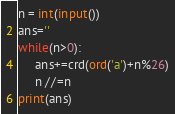Convert code to text. <code><loc_0><loc_0><loc_500><loc_500><_Python_>n = int(input())
ans=''
while(n>0):
     ans+=crd(ord('a')+n%26)
     n //=n
print(ans)</code> 